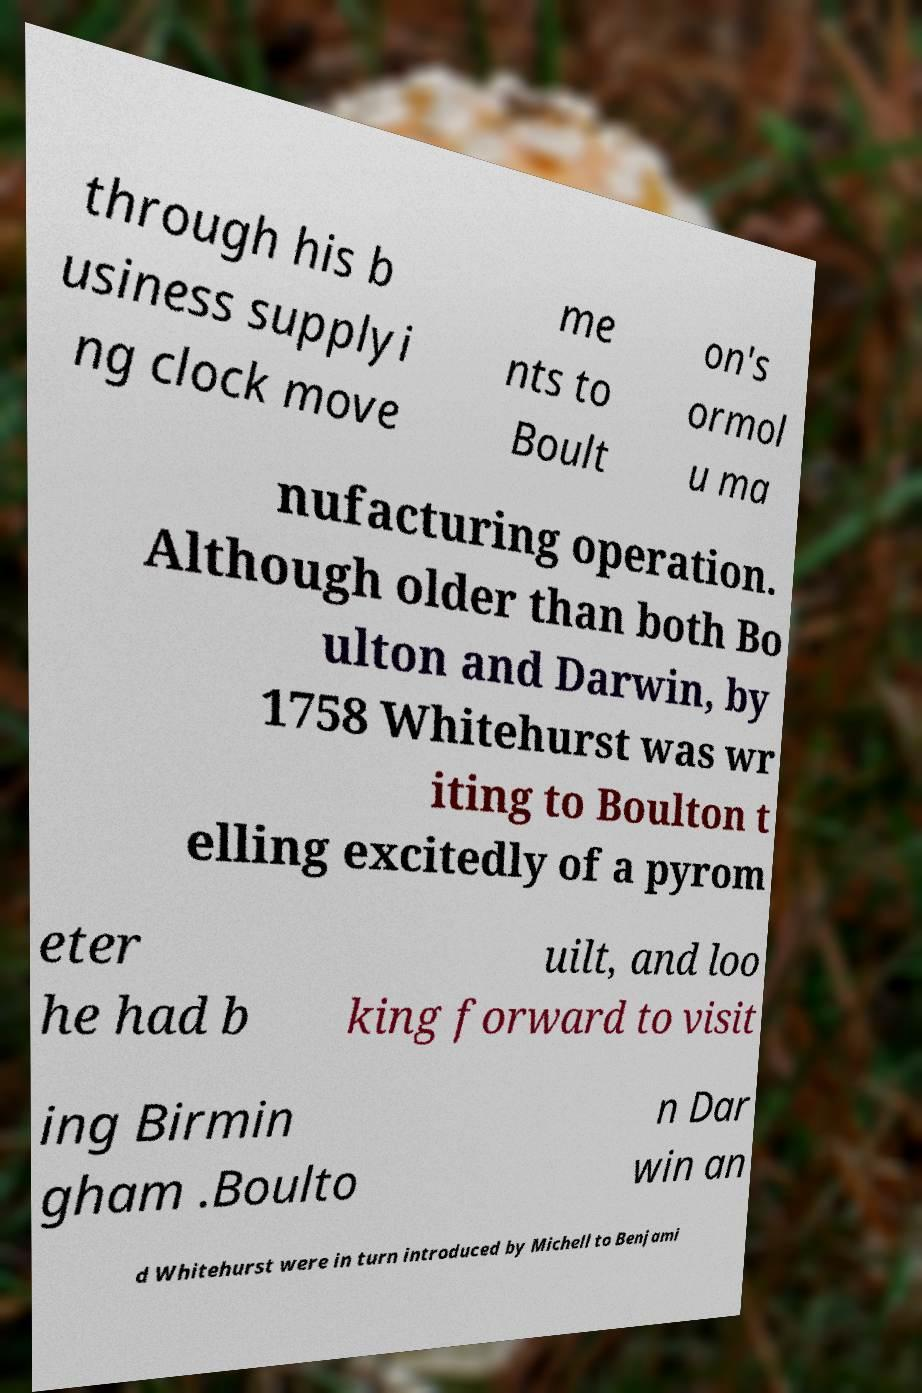I need the written content from this picture converted into text. Can you do that? through his b usiness supplyi ng clock move me nts to Boult on's ormol u ma nufacturing operation. Although older than both Bo ulton and Darwin, by 1758 Whitehurst was wr iting to Boulton t elling excitedly of a pyrom eter he had b uilt, and loo king forward to visit ing Birmin gham .Boulto n Dar win an d Whitehurst were in turn introduced by Michell to Benjami 